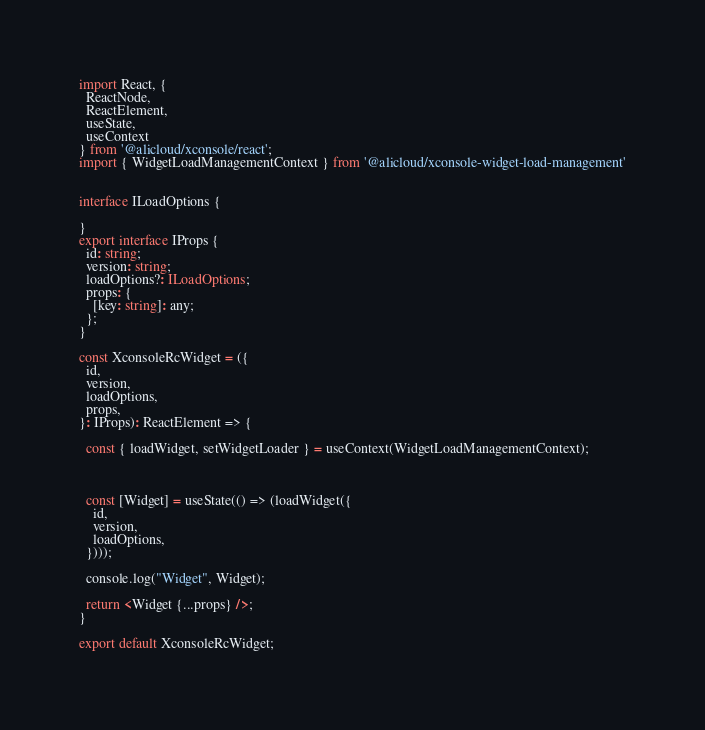<code> <loc_0><loc_0><loc_500><loc_500><_TypeScript_>import React, {
  ReactNode,
  ReactElement,
  useState,
  useContext
} from '@alicloud/xconsole/react';
import { WidgetLoadManagementContext } from '@alicloud/xconsole-widget-load-management'


interface ILoadOptions {

}
export interface IProps {
  id: string;
  version: string;
  loadOptions?: ILoadOptions;
  props: {
    [key: string]: any;
  };
}

const XconsoleRcWidget = ({
  id,
  version,
  loadOptions,
  props,
}: IProps): ReactElement => {

  const { loadWidget, setWidgetLoader } = useContext(WidgetLoadManagementContext);



  const [Widget] = useState(() => (loadWidget({
    id,
    version,
    loadOptions,
  })));

  console.log("Widget", Widget);

  return <Widget {...props} />;
}

export default XconsoleRcWidget;

</code> 